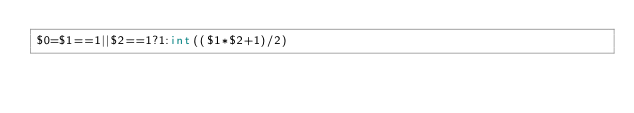Convert code to text. <code><loc_0><loc_0><loc_500><loc_500><_Awk_>$0=$1==1||$2==1?1:int(($1*$2+1)/2)</code> 